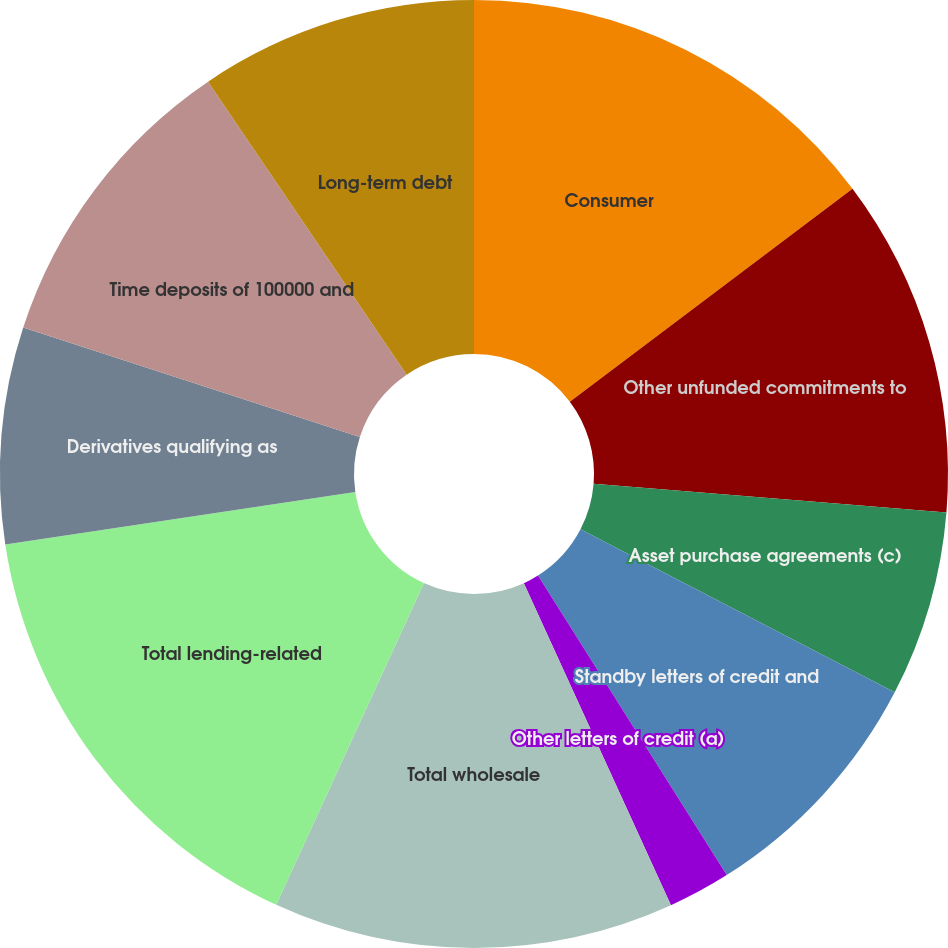Convert chart. <chart><loc_0><loc_0><loc_500><loc_500><pie_chart><fcel>Consumer<fcel>Other unfunded commitments to<fcel>Asset purchase agreements (c)<fcel>Standby letters of credit and<fcel>Other letters of credit (a)<fcel>Total wholesale<fcel>Total lending-related<fcel>Derivatives qualifying as<fcel>Time deposits of 100000 and<fcel>Long-term debt<nl><fcel>14.72%<fcel>11.57%<fcel>6.33%<fcel>8.43%<fcel>2.13%<fcel>13.67%<fcel>15.77%<fcel>7.38%<fcel>10.52%<fcel>9.48%<nl></chart> 